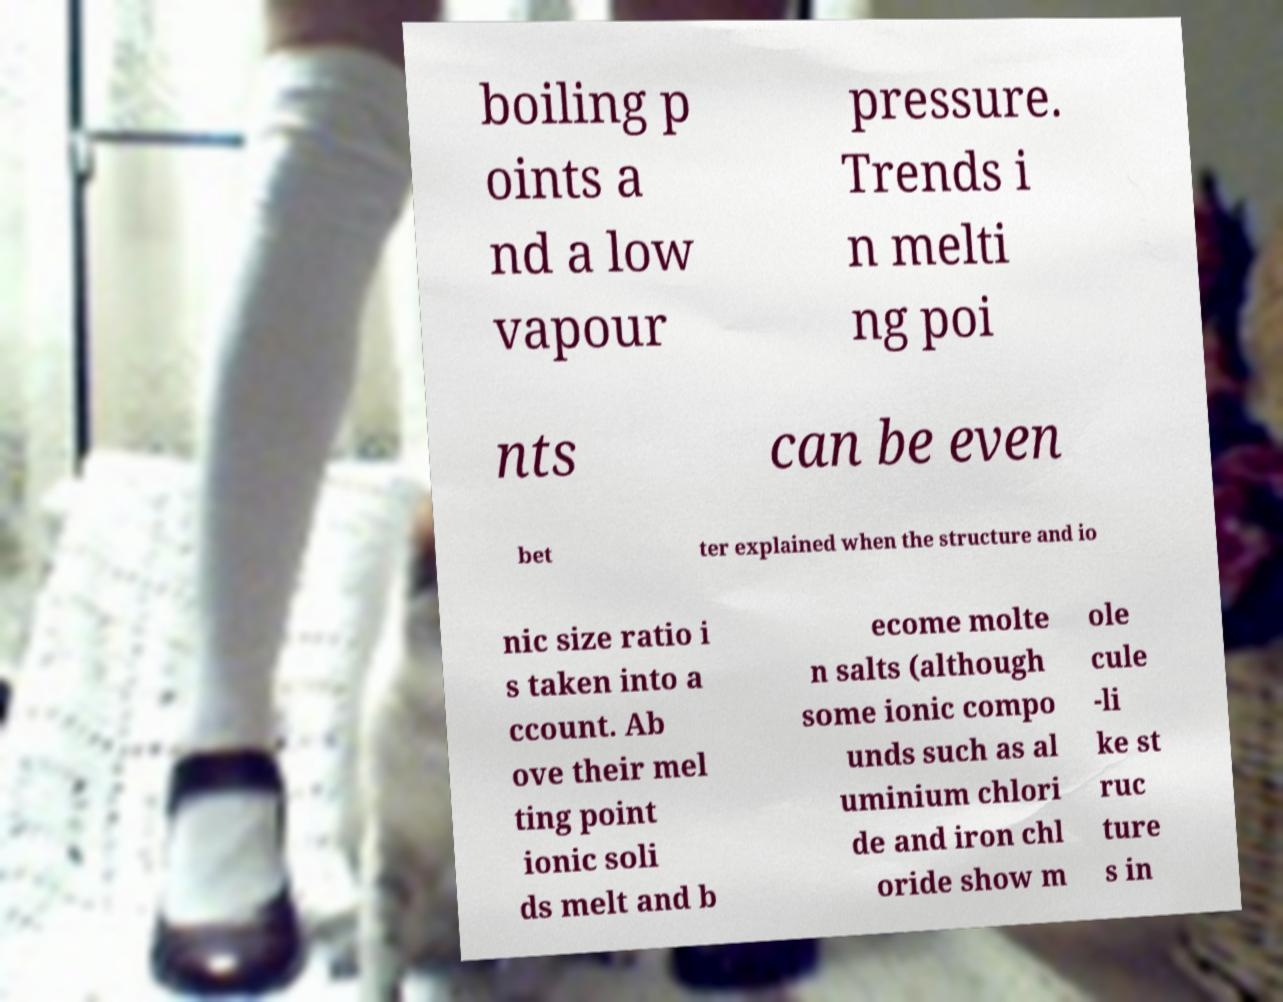Can you accurately transcribe the text from the provided image for me? boiling p oints a nd a low vapour pressure. Trends i n melti ng poi nts can be even bet ter explained when the structure and io nic size ratio i s taken into a ccount. Ab ove their mel ting point ionic soli ds melt and b ecome molte n salts (although some ionic compo unds such as al uminium chlori de and iron chl oride show m ole cule -li ke st ruc ture s in 